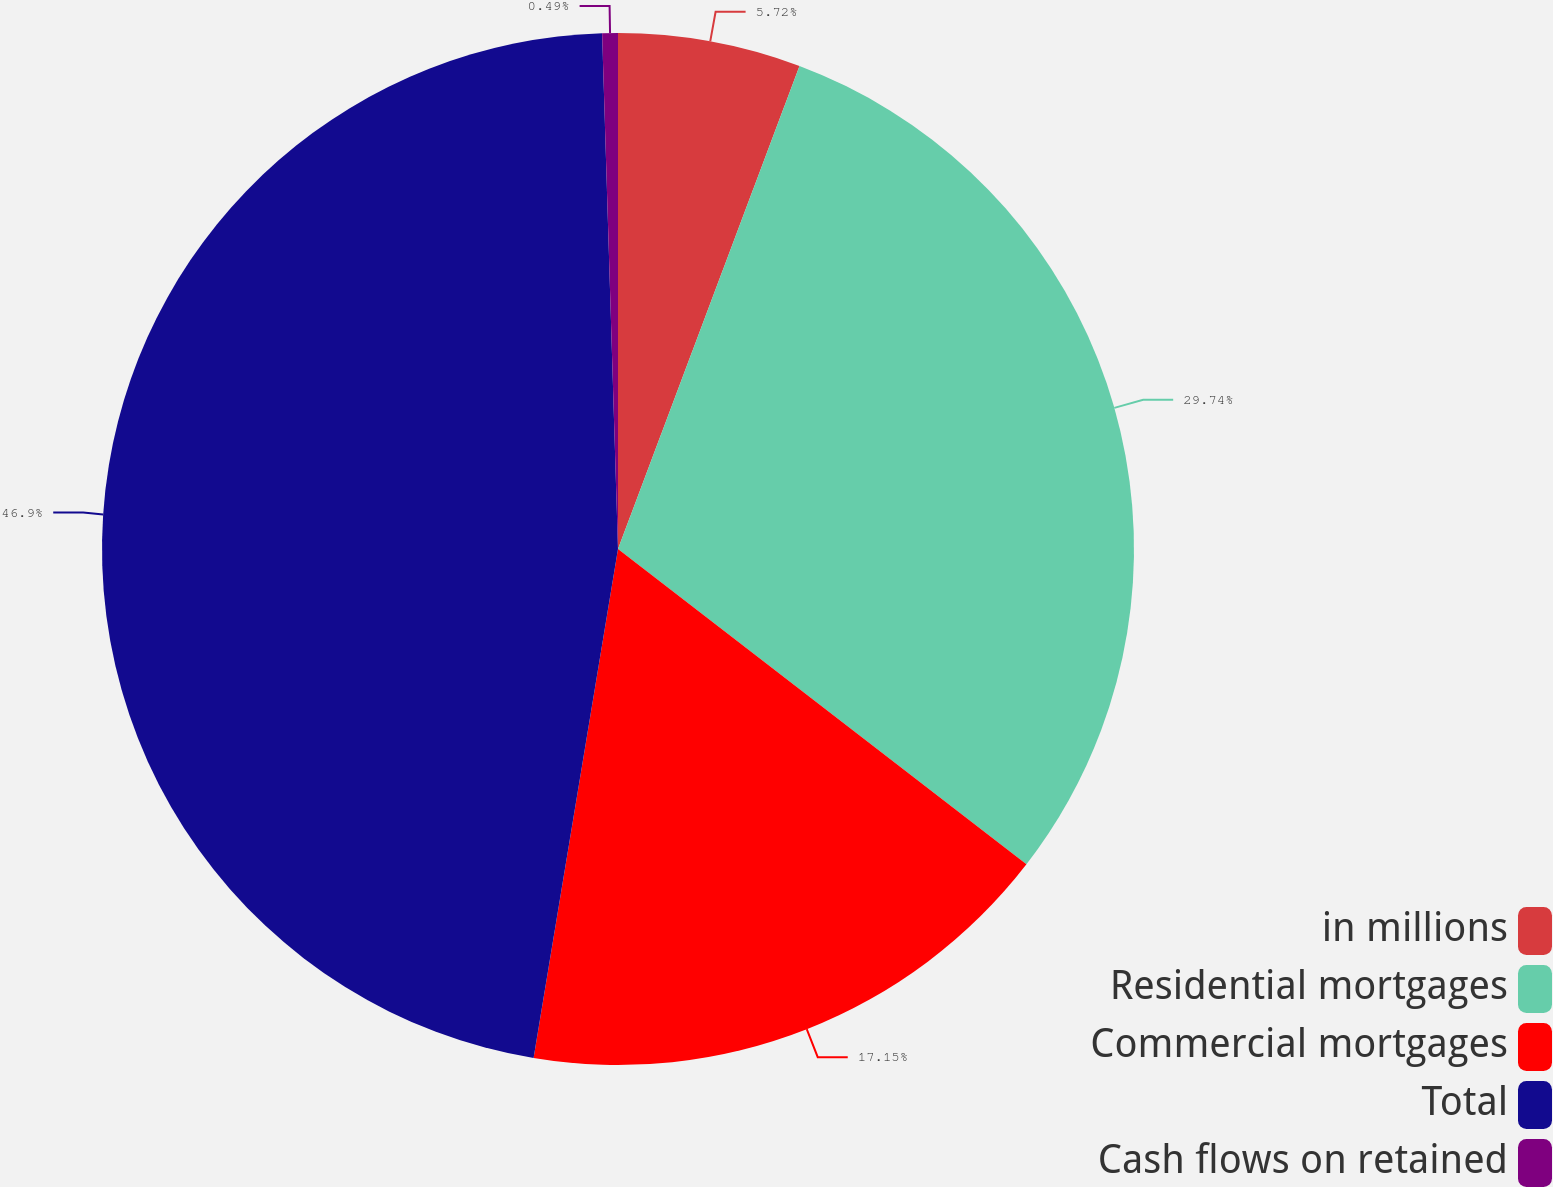Convert chart. <chart><loc_0><loc_0><loc_500><loc_500><pie_chart><fcel>in millions<fcel>Residential mortgages<fcel>Commercial mortgages<fcel>Total<fcel>Cash flows on retained<nl><fcel>5.72%<fcel>29.74%<fcel>17.15%<fcel>46.89%<fcel>0.49%<nl></chart> 